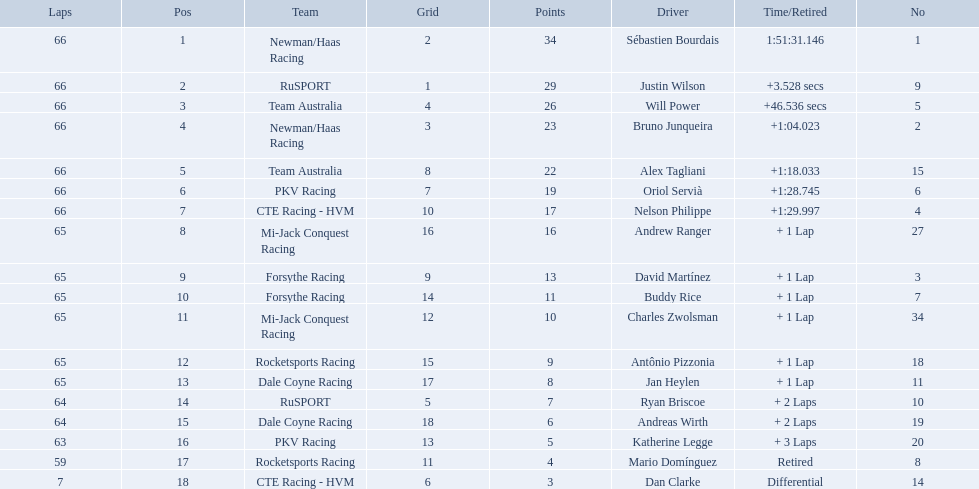How many points did first place receive? 34. How many did last place receive? 3. Who was the recipient of these last place points? Dan Clarke. Which people scored 29+ points? Sébastien Bourdais, Justin Wilson. Who scored higher? Sébastien Bourdais. What drivers started in the top 10? Sébastien Bourdais, Justin Wilson, Will Power, Bruno Junqueira, Alex Tagliani, Oriol Servià, Nelson Philippe, Ryan Briscoe, Dan Clarke. Which of those drivers completed all 66 laps? Sébastien Bourdais, Justin Wilson, Will Power, Bruno Junqueira, Alex Tagliani, Oriol Servià, Nelson Philippe. Whom of these did not drive for team australia? Sébastien Bourdais, Justin Wilson, Bruno Junqueira, Oriol Servià, Nelson Philippe. Which of these drivers finished more then a minuet after the winner? Bruno Junqueira, Oriol Servià, Nelson Philippe. Which of these drivers had the highest car number? Oriol Servià. 